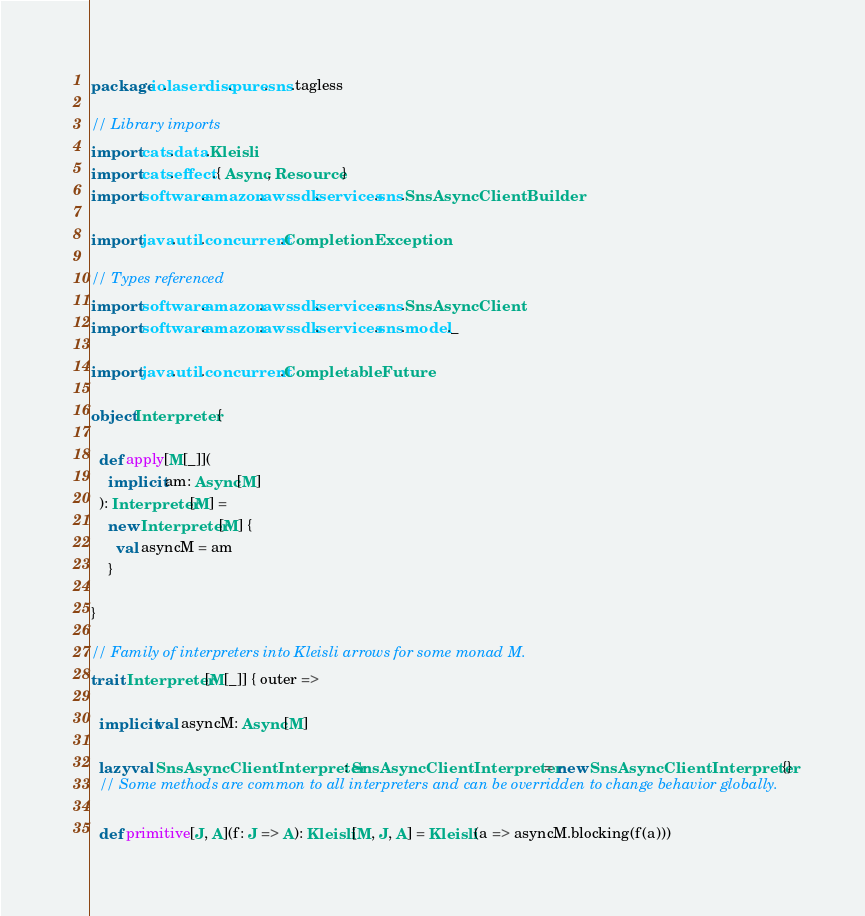<code> <loc_0><loc_0><loc_500><loc_500><_Scala_>package io.laserdisc.pure.sns.tagless

// Library imports
import cats.data.Kleisli
import cats.effect.{ Async, Resource }
import software.amazon.awssdk.services.sns.SnsAsyncClientBuilder

import java.util.concurrent.CompletionException

// Types referenced
import software.amazon.awssdk.services.sns.SnsAsyncClient
import software.amazon.awssdk.services.sns.model._

import java.util.concurrent.CompletableFuture

object Interpreter {

  def apply[M[_]](
    implicit am: Async[M]
  ): Interpreter[M] =
    new Interpreter[M] {
      val asyncM = am
    }

}

// Family of interpreters into Kleisli arrows for some monad M.
trait Interpreter[M[_]] { outer =>

  implicit val asyncM: Async[M]

  lazy val SnsAsyncClientInterpreter: SnsAsyncClientInterpreter = new SnsAsyncClientInterpreter {}
  // Some methods are common to all interpreters and can be overridden to change behavior globally.

  def primitive[J, A](f: J => A): Kleisli[M, J, A] = Kleisli(a => asyncM.blocking(f(a)))</code> 